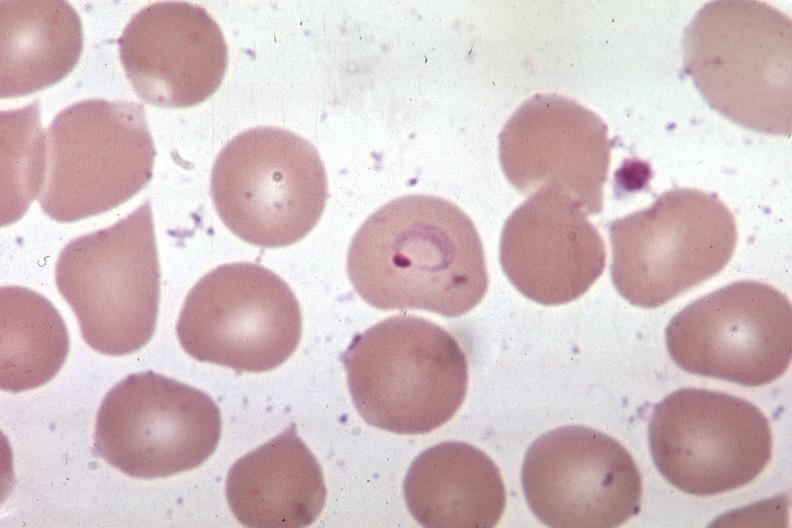s malaria plasmodium vivax present?
Answer the question using a single word or phrase. Yes 